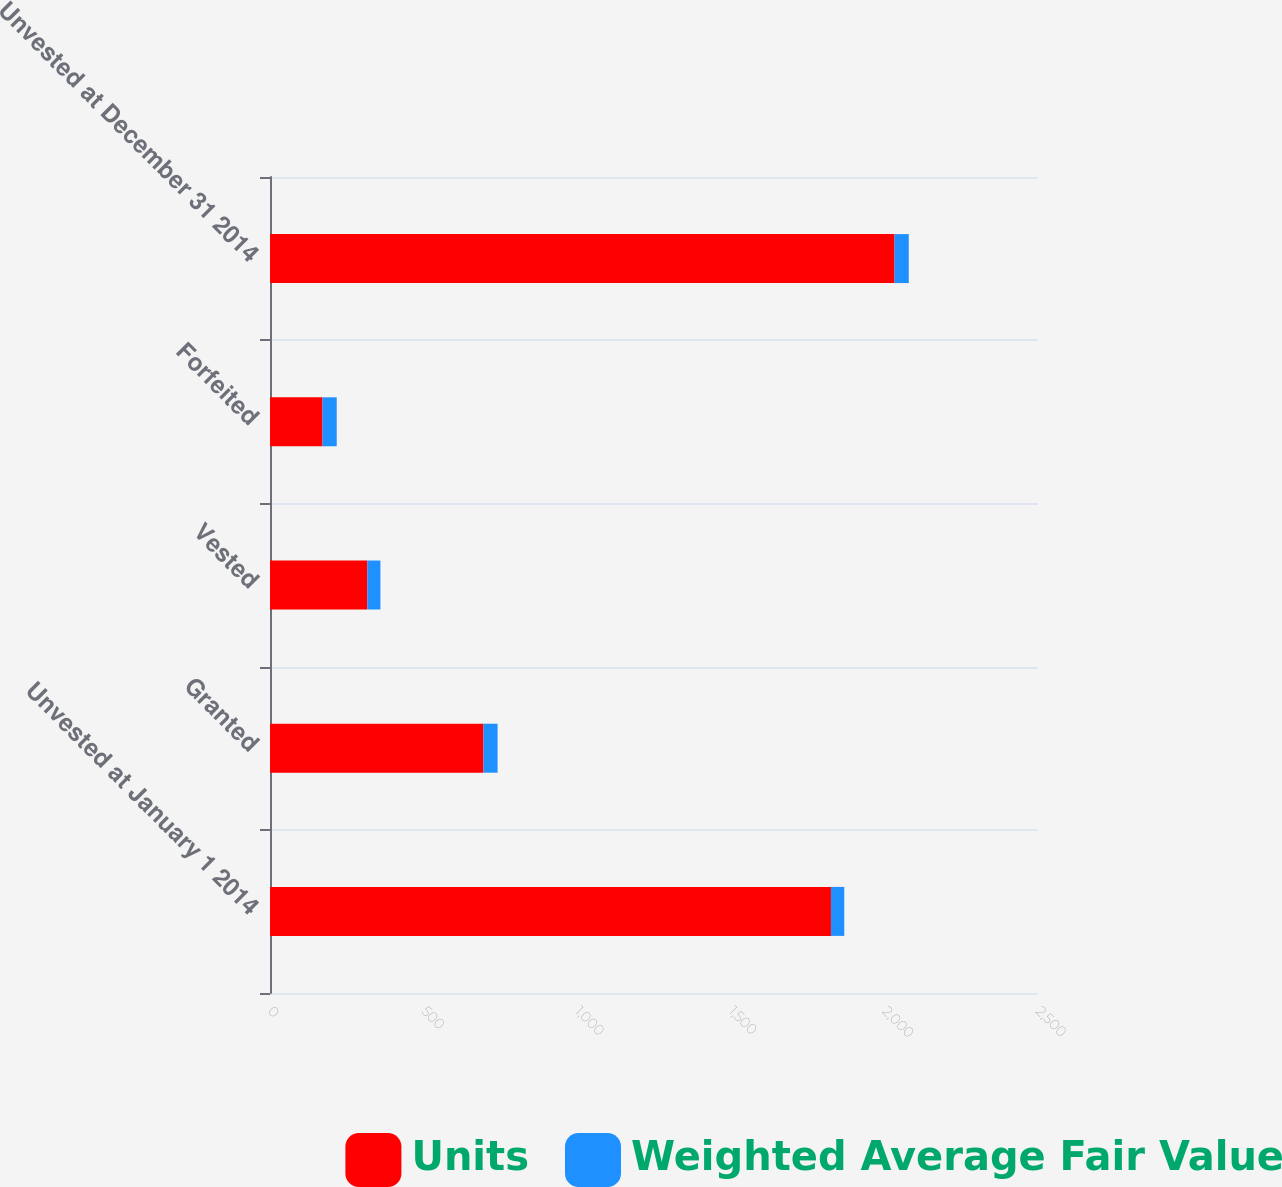<chart> <loc_0><loc_0><loc_500><loc_500><stacked_bar_chart><ecel><fcel>Unvested at January 1 2014<fcel>Granted<fcel>Vested<fcel>Forfeited<fcel>Unvested at December 31 2014<nl><fcel>Units<fcel>1826<fcel>695<fcel>317<fcel>171<fcel>2033<nl><fcel>Weighted Average Fair Value<fcel>43.41<fcel>45.83<fcel>42.42<fcel>46.2<fcel>46.28<nl></chart> 